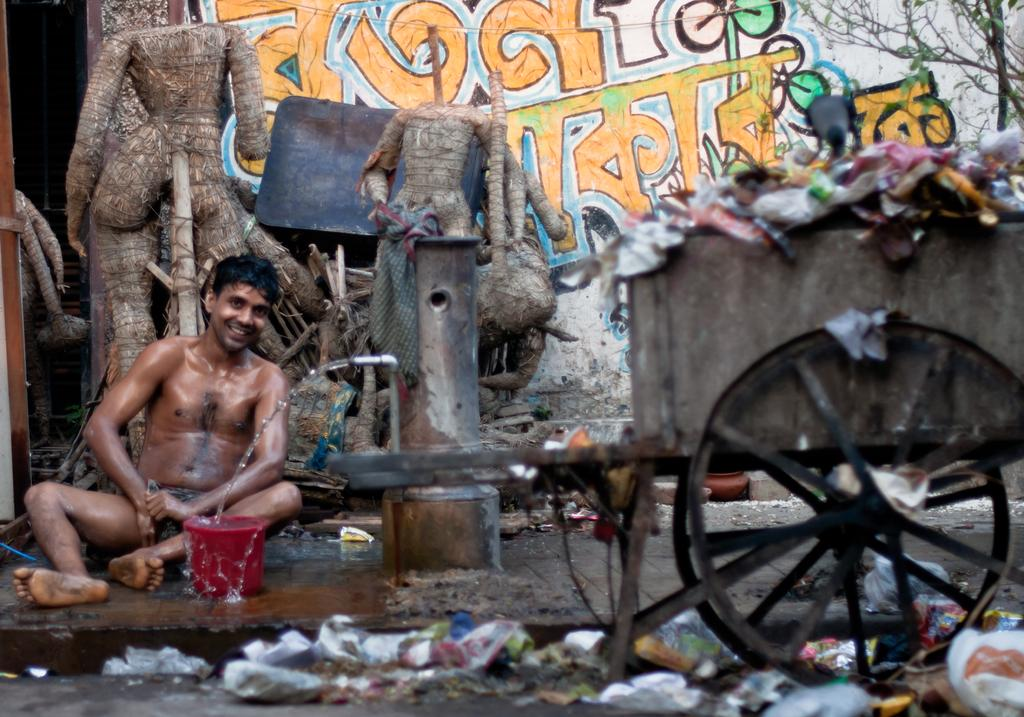What is the man in the image doing? The man in the image is doing bathing on the left side. Can you describe any objects related to water in the image? Yes, there is a tap in the image. What is located on the right side of the image? There is a dustbin vehicle on the right side of the image. What type of recess can be seen in the image? There is no recess present in the image. What season is depicted in the image, considering the presence of spring flowers? There is no mention of spring flowers or any seasonal elements in the image. 